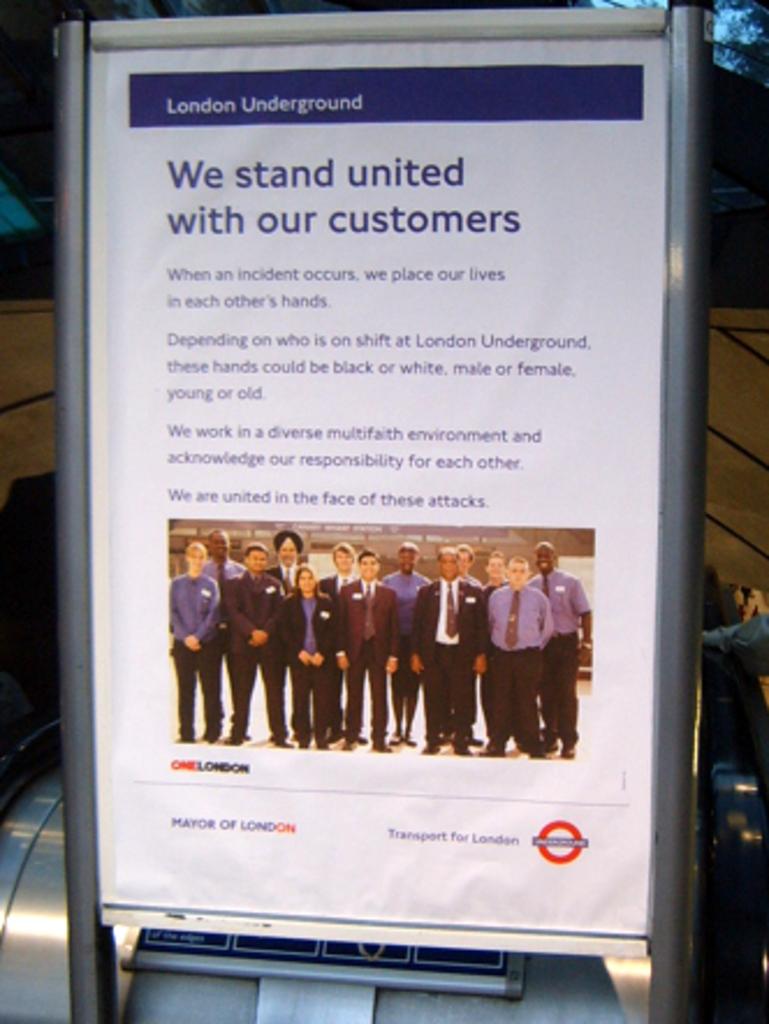Where is the underground?
Keep it short and to the point. London. What do they do with their customers?
Make the answer very short. Stand united. 